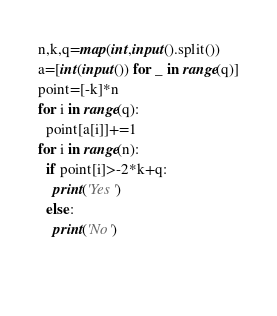<code> <loc_0><loc_0><loc_500><loc_500><_Python_>n,k,q=map(int,input().split())
a=[int(input()) for _ in range(q)]
point=[-k]*n
for i in range(q):
  point[a[i]]+=1
for i in range(n):
  if point[i]>-2*k+q:
    print('Yes')
  else:
    print('No')
    
  
</code> 